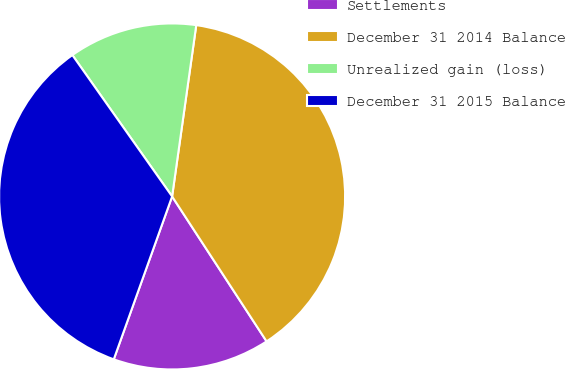<chart> <loc_0><loc_0><loc_500><loc_500><pie_chart><fcel>Settlements<fcel>December 31 2014 Balance<fcel>Unrealized gain (loss)<fcel>December 31 2015 Balance<nl><fcel>14.67%<fcel>38.58%<fcel>12.01%<fcel>34.75%<nl></chart> 